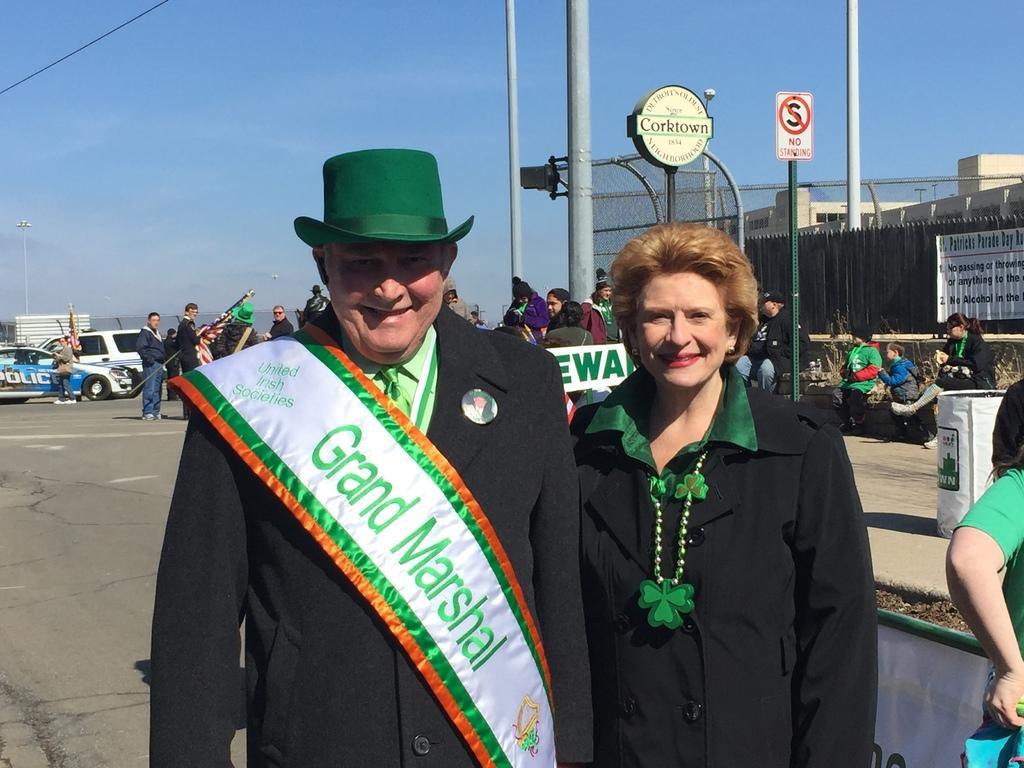Can you describe this image briefly? In the image we can see a man and a woman wearing clothes and they are smiling. The woman is wearing neck chain and the man is wearing a hat and batch. We can see there are many poles and buildings. There are even other people standing. We can see road electric wire fence, poster and the sky. 